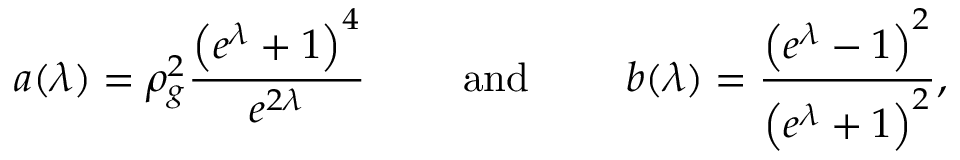Convert formula to latex. <formula><loc_0><loc_0><loc_500><loc_500>a ( \lambda ) = \rho _ { g } ^ { 2 } \frac { \left ( e ^ { \lambda } + 1 \right ) ^ { 4 } } { e ^ { 2 \lambda } } \quad a n d \quad b ( \lambda ) = \frac { \left ( e ^ { \lambda } - 1 \right ) ^ { 2 } } { \left ( e ^ { \lambda } + 1 \right ) ^ { 2 } } ,</formula> 